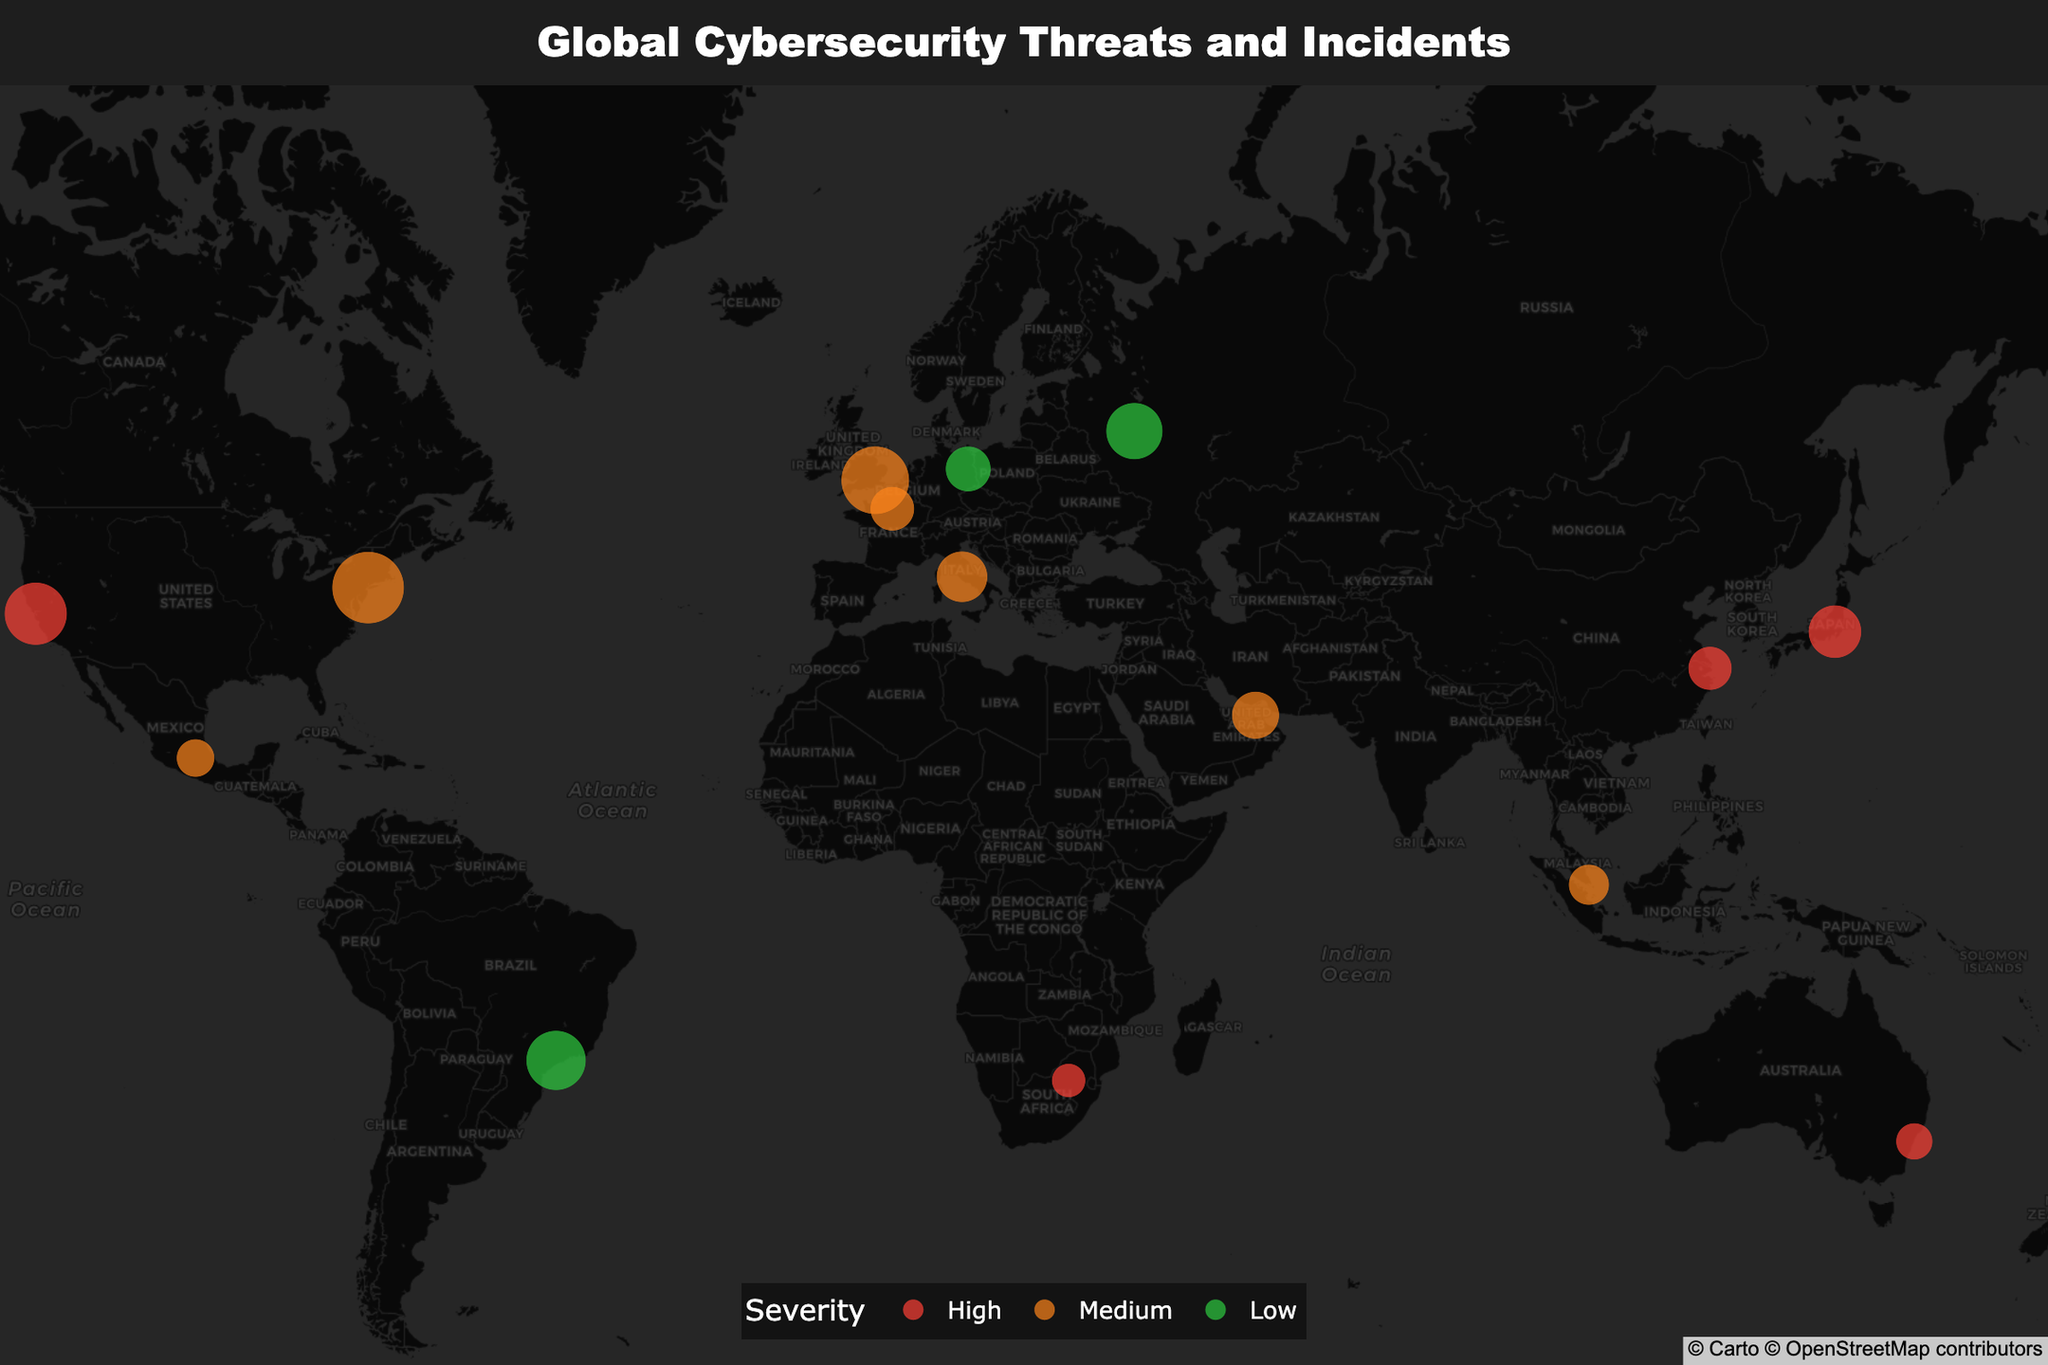How many cybersecurity incidents are plotted on the map? Count the number of data points plotted on the map, which represents the number of incidents.
Answer: 15 Which location has the highest incident count? Locate the incident with the largest circle size, as size represents incident count. The largest circle is in New York City.
Answer: New York City What is the severity of the threat in Tokyo? Hover over or find the Tokyo data point on the map and read off the severity information.
Answer: High Which city has the lowest incident count? Identify the smallest circle on the map which corresponds to the city with the lowest incident count.
Answer: Johannesburg Compare the incident count between Berlin and Paris. Which has more incidents? Find the incident count for both Berlin and Paris from the hover information and compare. Berlin has 41 incidents and Paris has 39.
Answer: Berlin Which threat type is most frequent in locations with medium severity? From the map, locate the cities with medium severity (color-coded accordingly) and check their threat types. Both New York City (DDoS) and London (Phishing) have medium severity, but Phishing is most frequent with 92 incidents vs. DDoS's 103.
Answer: DDoS What is the average incident count for cities with high severity threats? Find and sum the incident counts for San Francisco (78), Tokyo (56), Shanghai (38), Sydney (27), and Johannesburg (23), then divide by the number of cities (5). The total is 222, and the average is 222/5.
Answer: 44.4 How does the incident count in Moscow compare to that in Sao Paulo? Find and compare the incident counts: Moscow has 64 incidents, whereas Sao Paulo has 71.
Answer: Sao Paulo Which region has a lower incident count, Europe or Asia? Sum the incident counts for European cities (London, Berlin, Paris, Rome, Moscow) = 92 + 41 + 39 + 52 + 64 = 288 and Asian cities (Tokyo, Singapore, Shanghai) = 56 + 33 + 38 = 127. Europe has a higher count.
Answer: Asia What threat type is present in Sydney, and what is its incident count? Locate Sydney on the map and read the threat type and incident count.
Answer: Zero-Day Exploit, 27 